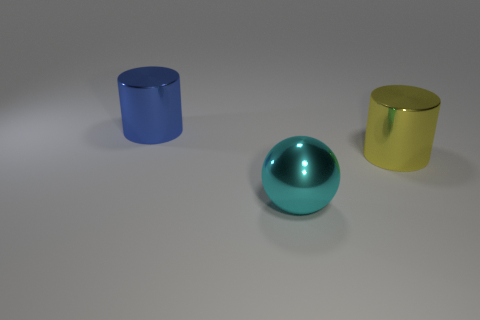How big is the thing that is both left of the big yellow shiny cylinder and on the right side of the blue shiny cylinder?
Your response must be concise. Large. There is a yellow object that is the same material as the ball; what size is it?
Provide a short and direct response. Large. The blue object that is the same shape as the big yellow thing is what size?
Ensure brevity in your answer.  Large. How many things are big cylinders to the right of the shiny sphere or big yellow shiny objects?
Give a very brief answer. 1. Are there any other things that are the same material as the big yellow cylinder?
Offer a very short reply. Yes. How many objects are either big metal things right of the large blue cylinder or big spheres that are left of the large yellow metallic cylinder?
Your response must be concise. 2. Is the material of the cyan ball the same as the cylinder that is on the right side of the large blue shiny object?
Your response must be concise. Yes. The shiny thing that is behind the large cyan sphere and in front of the large blue object has what shape?
Your answer should be very brief. Cylinder. What number of other objects are there of the same color as the sphere?
Provide a short and direct response. 0. What is the shape of the big cyan shiny object?
Provide a short and direct response. Sphere. 